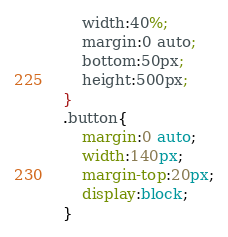<code> <loc_0><loc_0><loc_500><loc_500><_CSS_>    width:40%;
    margin:0 auto;
    bottom:50px;
    height:500px;
}
.button{
    margin:0 auto;
    width:140px;
    margin-top:20px;
    display:block;
}</code> 